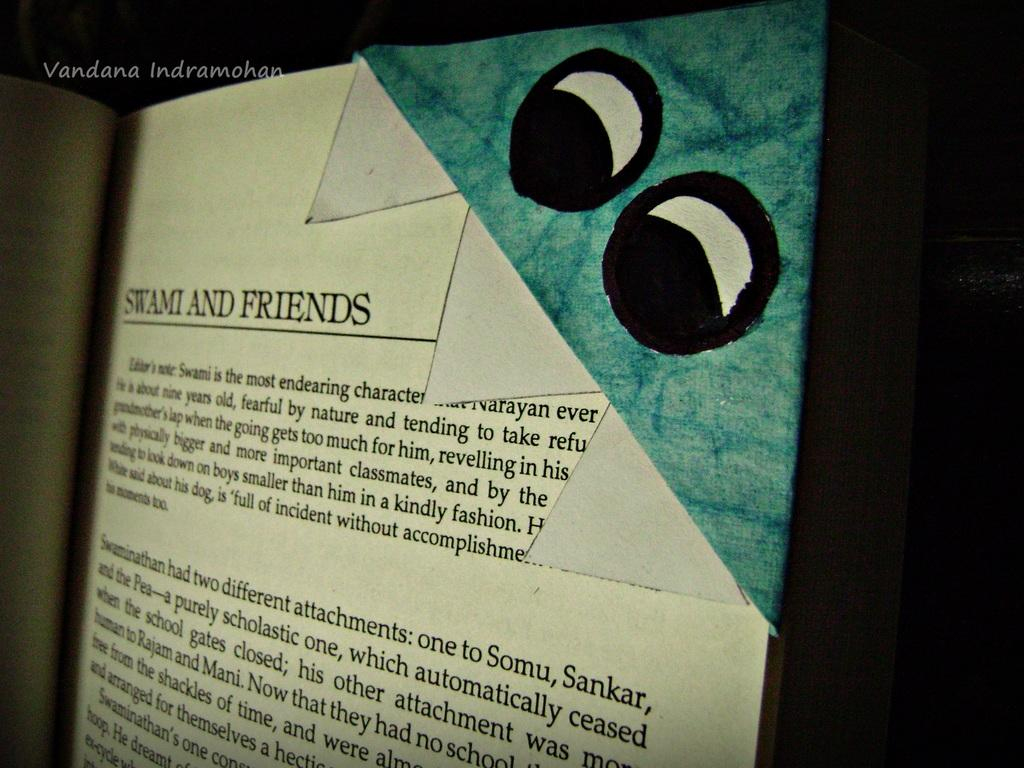Provide a one-sentence caption for the provided image. A page of a book called Stami and Friends with eyes. 